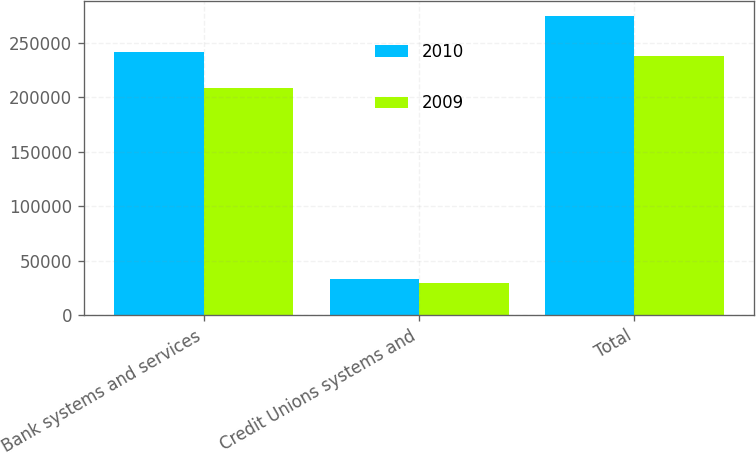<chart> <loc_0><loc_0><loc_500><loc_500><stacked_bar_chart><ecel><fcel>Bank systems and services<fcel>Credit Unions systems and<fcel>Total<nl><fcel>2010<fcel>241596<fcel>33074<fcel>274670<nl><fcel>2009<fcel>208488<fcel>29290<fcel>237778<nl></chart> 